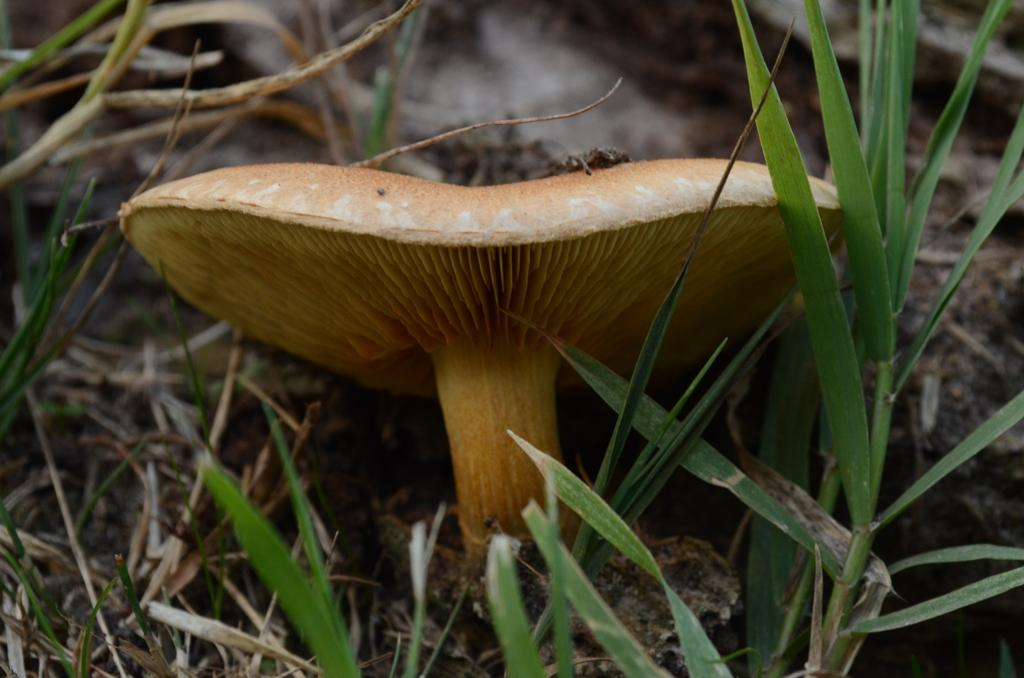What type of vegetation is present in the image? There is grass in the image. Are there any other natural elements visible in the image? Yes, there is a mushroom in the image. What type of vegetable is hanging from the swing in the image? There is no vegetable or swing present in the image. 